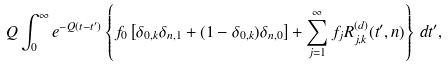Convert formula to latex. <formula><loc_0><loc_0><loc_500><loc_500>Q \int _ { 0 } ^ { \infty } e ^ { - Q ( t - t ^ { \prime } ) } \left \{ f _ { 0 } \left [ \delta _ { 0 , k } \delta _ { n , 1 } + ( 1 - \delta _ { 0 , k } ) \delta _ { n , 0 } \right ] + \sum _ { j = 1 } ^ { \infty } f _ { j } R _ { j , k } ^ { ( d ) } ( t ^ { \prime } , n ) \right \} \, d t ^ { \prime } ,</formula> 